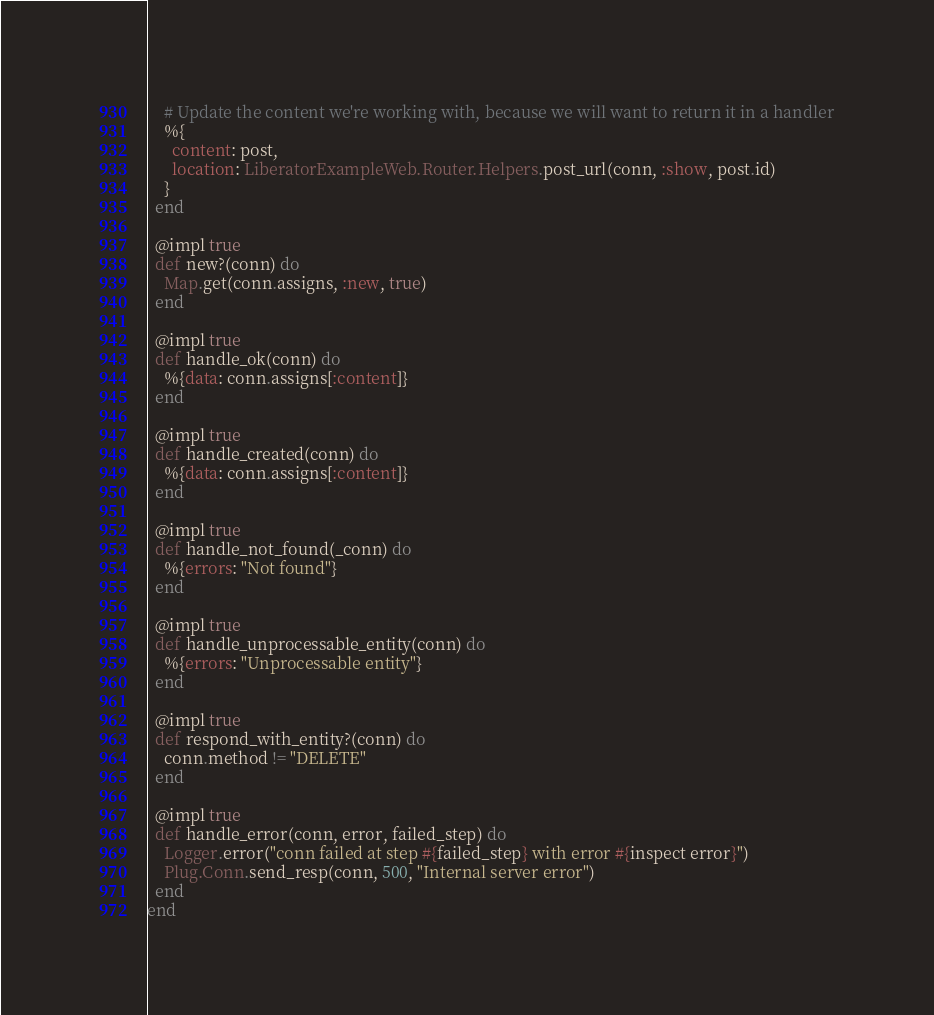<code> <loc_0><loc_0><loc_500><loc_500><_Elixir_>    # Update the content we're working with, because we will want to return it in a handler
    %{
      content: post,
      location: LiberatorExampleWeb.Router.Helpers.post_url(conn, :show, post.id)
    }
  end

  @impl true
  def new?(conn) do
    Map.get(conn.assigns, :new, true)
  end

  @impl true
  def handle_ok(conn) do
    %{data: conn.assigns[:content]}
  end

  @impl true
  def handle_created(conn) do
    %{data: conn.assigns[:content]}
  end

  @impl true
  def handle_not_found(_conn) do
    %{errors: "Not found"}
  end

  @impl true
  def handle_unprocessable_entity(conn) do
    %{errors: "Unprocessable entity"}
  end

  @impl true
  def respond_with_entity?(conn) do
    conn.method != "DELETE"
  end

  @impl true
  def handle_error(conn, error, failed_step) do
    Logger.error("conn failed at step #{failed_step} with error #{inspect error}")
    Plug.Conn.send_resp(conn, 500, "Internal server error")
  end
end
</code> 